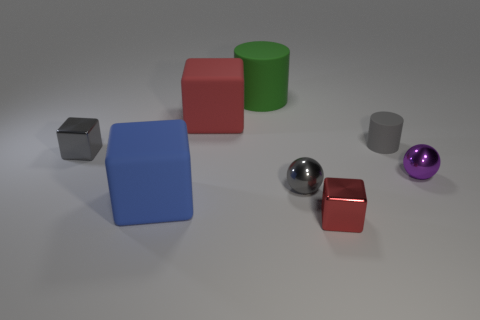Subtract all tiny gray blocks. How many blocks are left? 3 Subtract all green cylinders. How many cylinders are left? 1 Add 1 purple matte blocks. How many objects exist? 9 Subtract 1 cylinders. How many cylinders are left? 1 Subtract all green cubes. How many brown cylinders are left? 0 Subtract all red metallic objects. Subtract all small purple shiny balls. How many objects are left? 6 Add 5 large red matte blocks. How many large red matte blocks are left? 6 Add 6 big red rubber things. How many big red rubber things exist? 7 Subtract 2 red blocks. How many objects are left? 6 Subtract all balls. How many objects are left? 6 